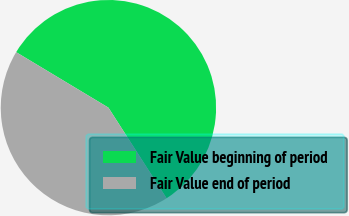Convert chart. <chart><loc_0><loc_0><loc_500><loc_500><pie_chart><fcel>Fair Value beginning of period<fcel>Fair Value end of period<nl><fcel>57.3%<fcel>42.7%<nl></chart> 